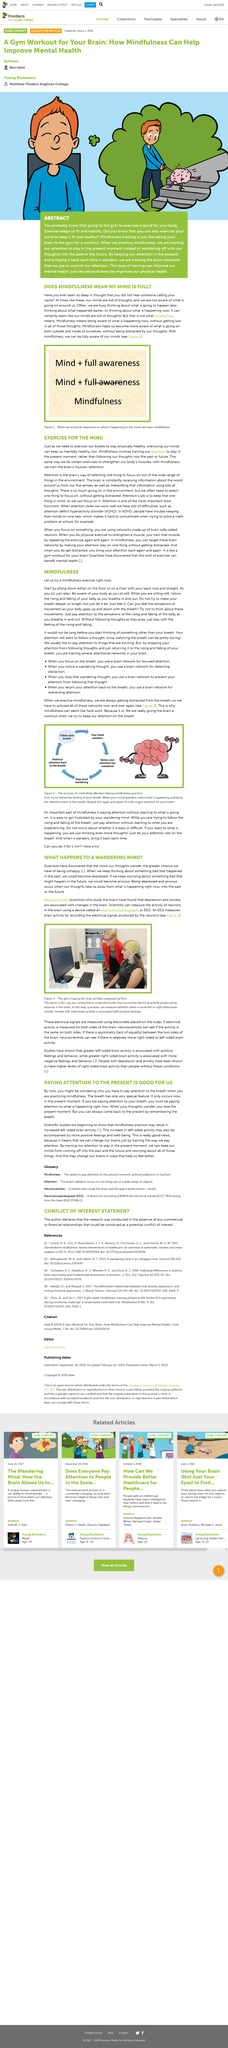Point out several critical features in this image. The stages of controlling attention during mindfulness practice include focusing on the breath, noticing when the mind wanders, stopping the mind from wandering, and redirecting attention back to the breath. When participating in a breathing mindfulness exercise, it is important to notice and return your attention to your breath if you become distracted. It is not true that mindfulness means that one's mind is full of thoughts, but rather it is a state of being fully aware of both internal and external experiences without being distracted by thoughts. Mindfulness is not considered to be a state of being distracted from the world around us, but rather a state of being aware of both the external and internal experiences without distraction. The equation 'mind + full awareness' equals mindfulness. 